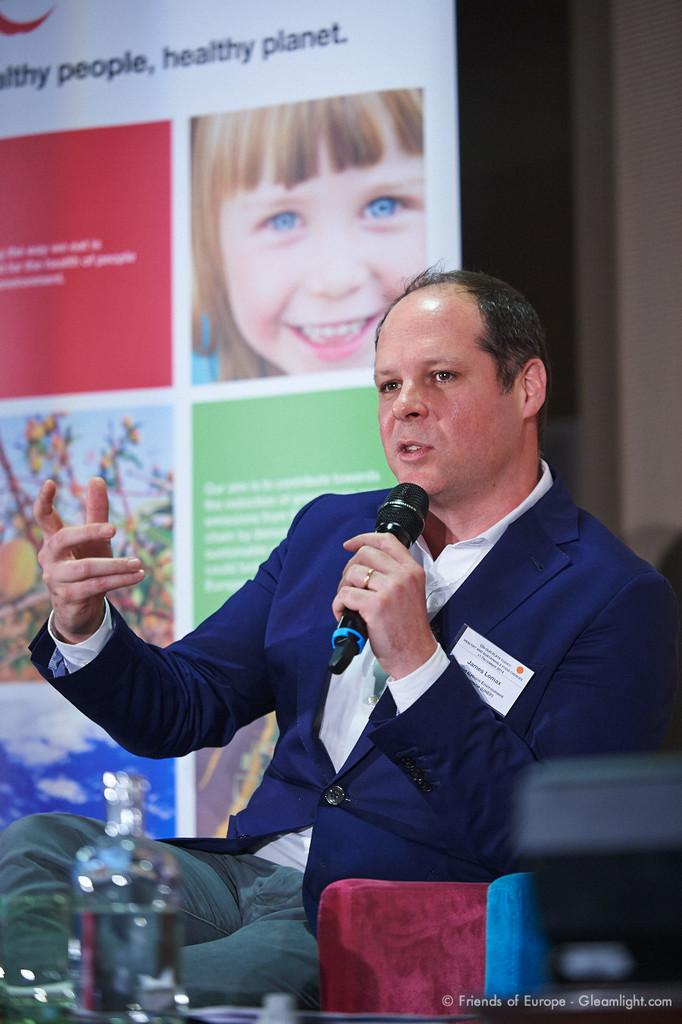Who is the main subject in the image? There is a man in the image. What is the man wearing? The man is wearing a black suit. What is the man doing in the image? The man is sitting on a chair and holding a microphone in his hand. What can be seen in the background of the image? There is a banner board in the background of the image. What type of mist is visible in the image? There is no mist present in the image. How does the man turn the protest around in the image? There is no protest or turning involved in the image; the man is sitting and holding a microphone. 